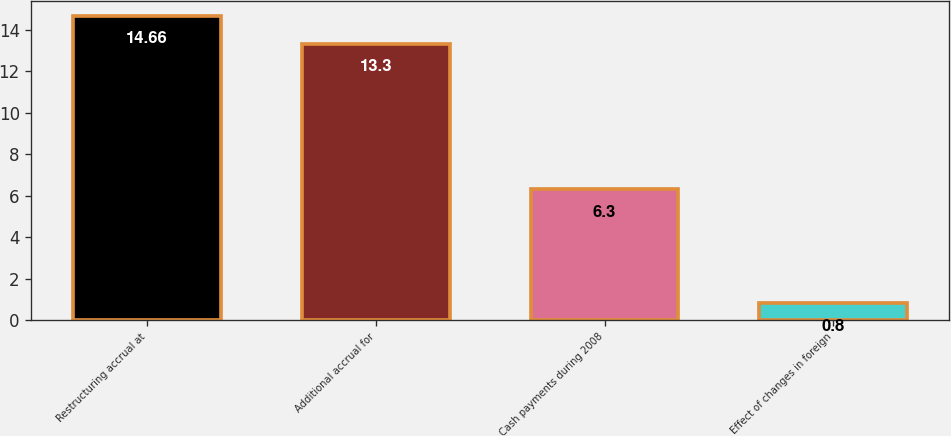Convert chart to OTSL. <chart><loc_0><loc_0><loc_500><loc_500><bar_chart><fcel>Restructuring accrual at<fcel>Additional accrual for<fcel>Cash payments during 2008<fcel>Effect of changes in foreign<nl><fcel>14.66<fcel>13.3<fcel>6.3<fcel>0.8<nl></chart> 